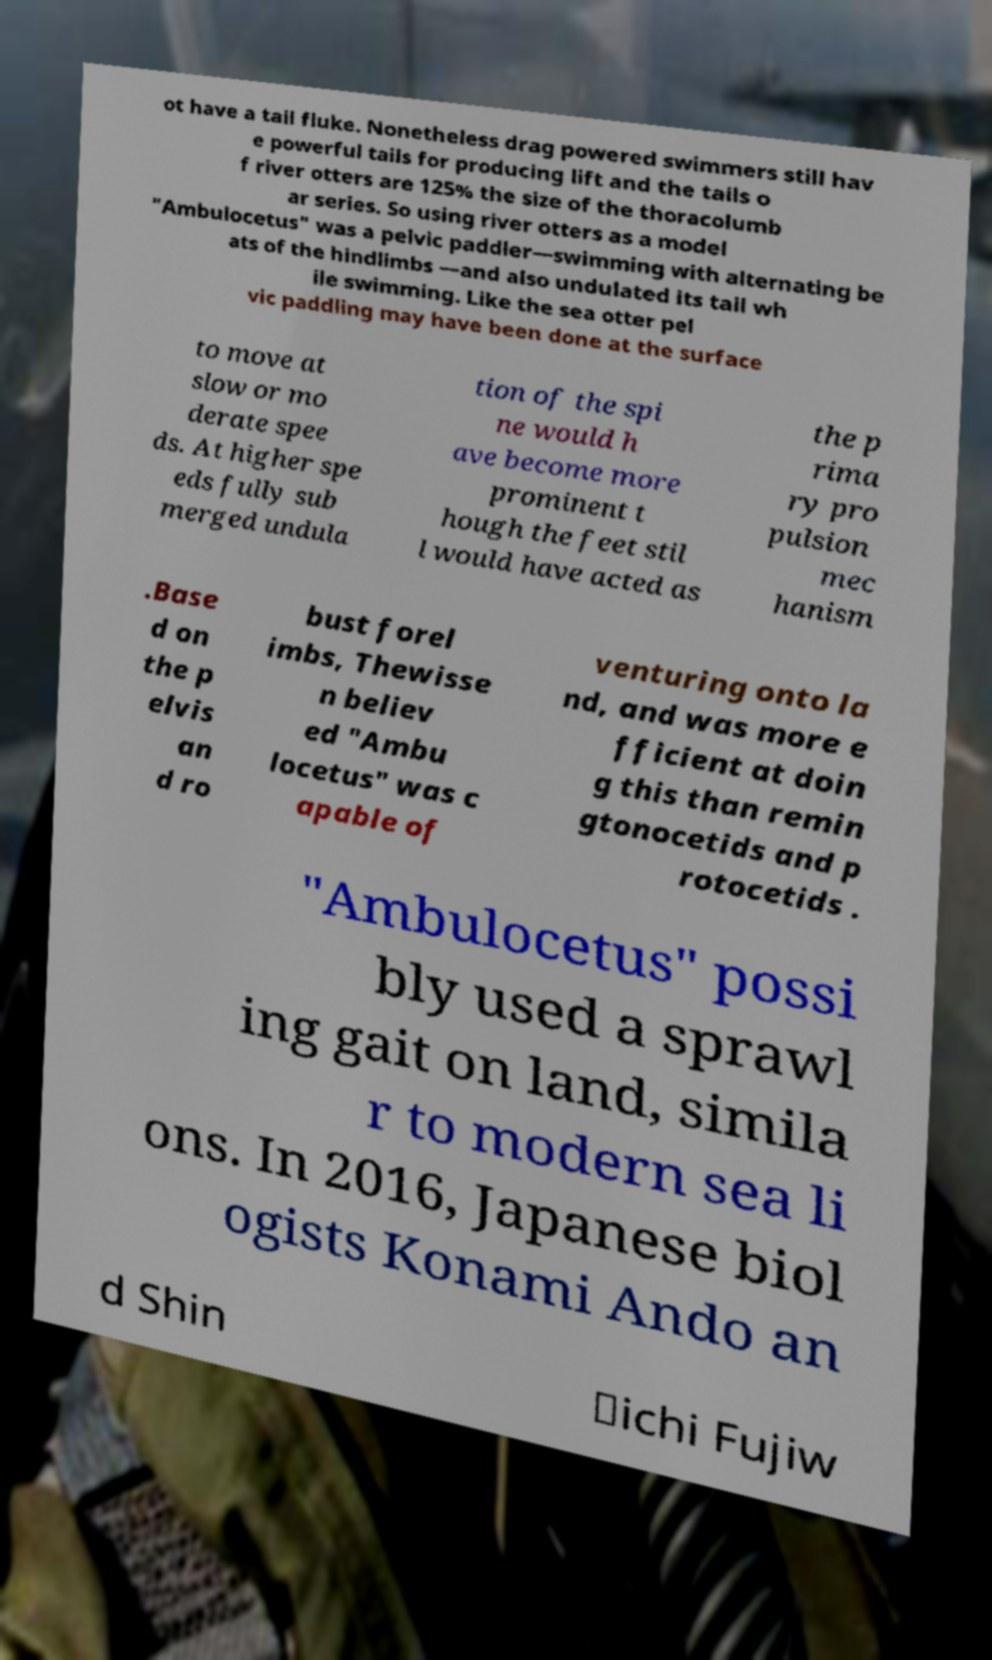I need the written content from this picture converted into text. Can you do that? ot have a tail fluke. Nonetheless drag powered swimmers still hav e powerful tails for producing lift and the tails o f river otters are 125% the size of the thoracolumb ar series. So using river otters as a model "Ambulocetus" was a pelvic paddler—swimming with alternating be ats of the hindlimbs —and also undulated its tail wh ile swimming. Like the sea otter pel vic paddling may have been done at the surface to move at slow or mo derate spee ds. At higher spe eds fully sub merged undula tion of the spi ne would h ave become more prominent t hough the feet stil l would have acted as the p rima ry pro pulsion mec hanism .Base d on the p elvis an d ro bust forel imbs, Thewisse n believ ed "Ambu locetus" was c apable of venturing onto la nd, and was more e fficient at doin g this than remin gtonocetids and p rotocetids . "Ambulocetus" possi bly used a sprawl ing gait on land, simila r to modern sea li ons. In 2016, Japanese biol ogists Konami Ando an d Shin ‐ichi Fujiw 